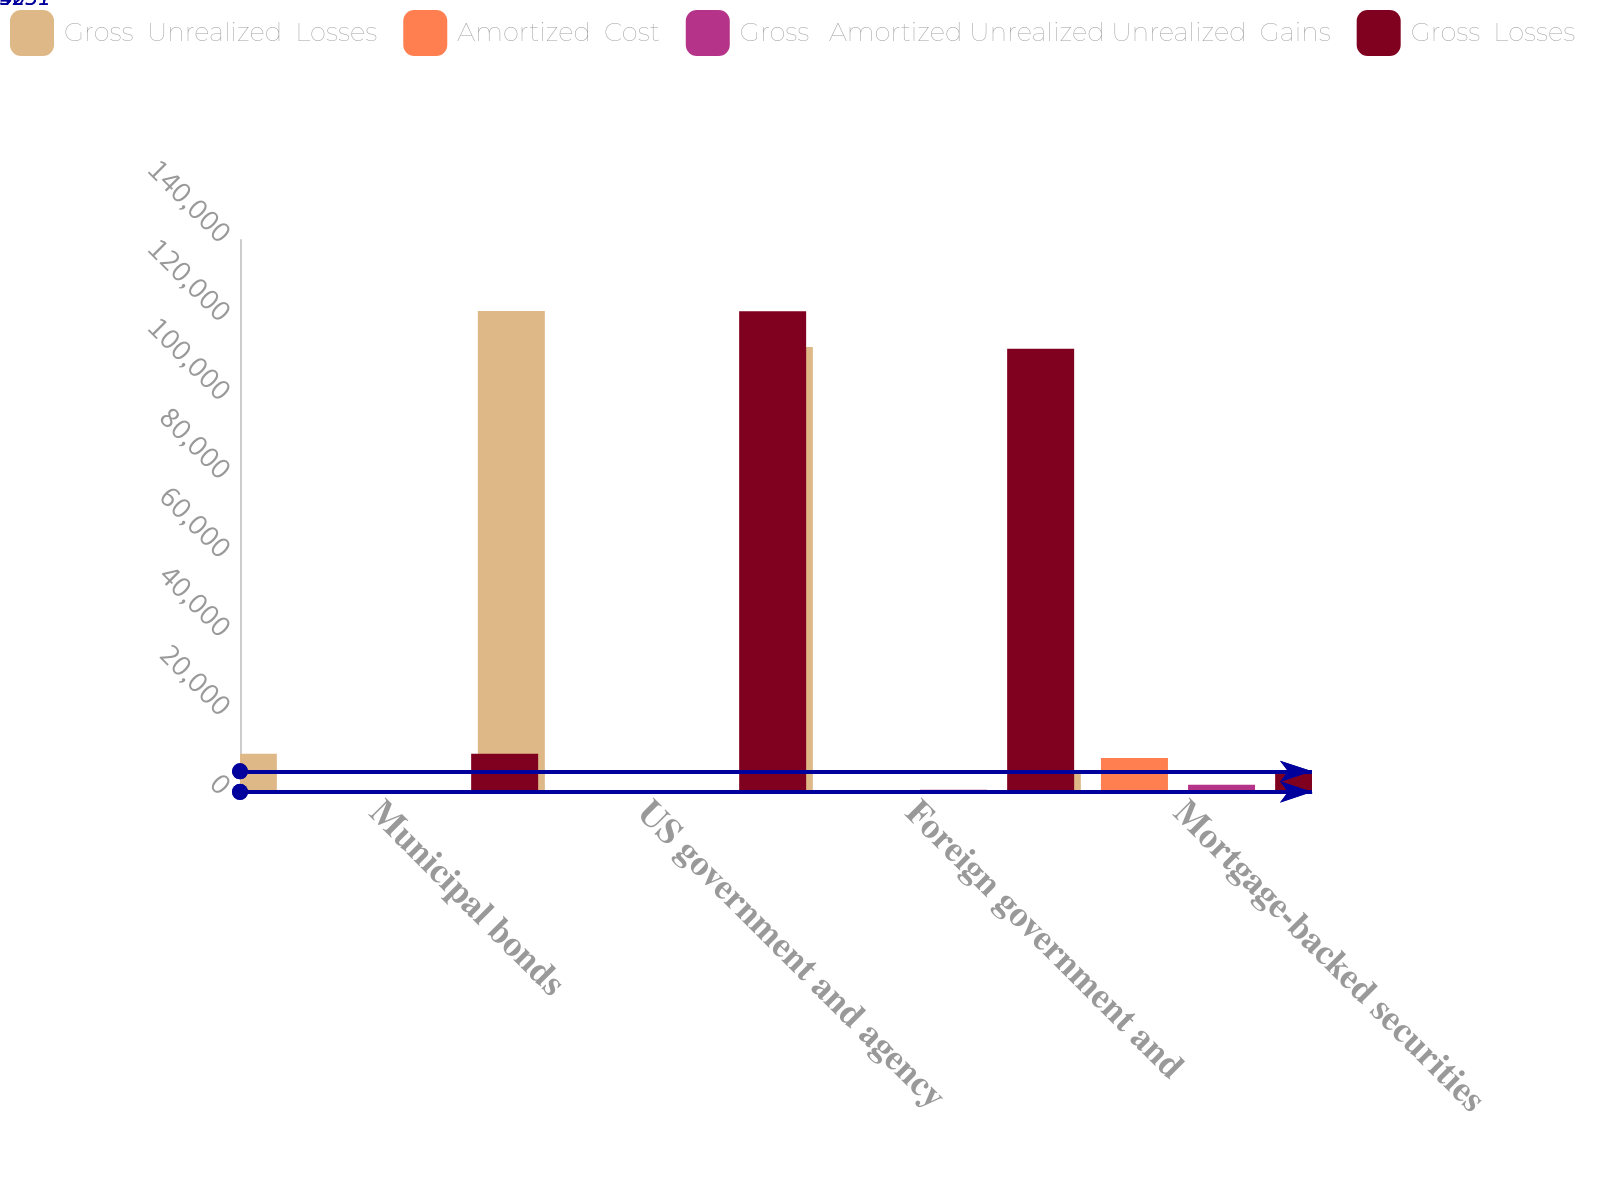Convert chart. <chart><loc_0><loc_0><loc_500><loc_500><stacked_bar_chart><ecel><fcel>Municipal bonds<fcel>US government and agency<fcel>Foreign government and<fcel>Mortgage-backed securities<nl><fcel>Gross  Unrealized  Losses<fcel>9688<fcel>121991<fcel>112852<fcel>5231<nl><fcel>Amortized  Cost<fcel>75<fcel>5<fcel>142<fcel>8643<nl><fcel>Gross   Amortized Unrealized Unrealized  Gains<fcel>60<fcel>40<fcel>564<fcel>1819<nl><fcel>Gross  Losses<fcel>9703<fcel>121956<fcel>112430<fcel>5231<nl></chart> 